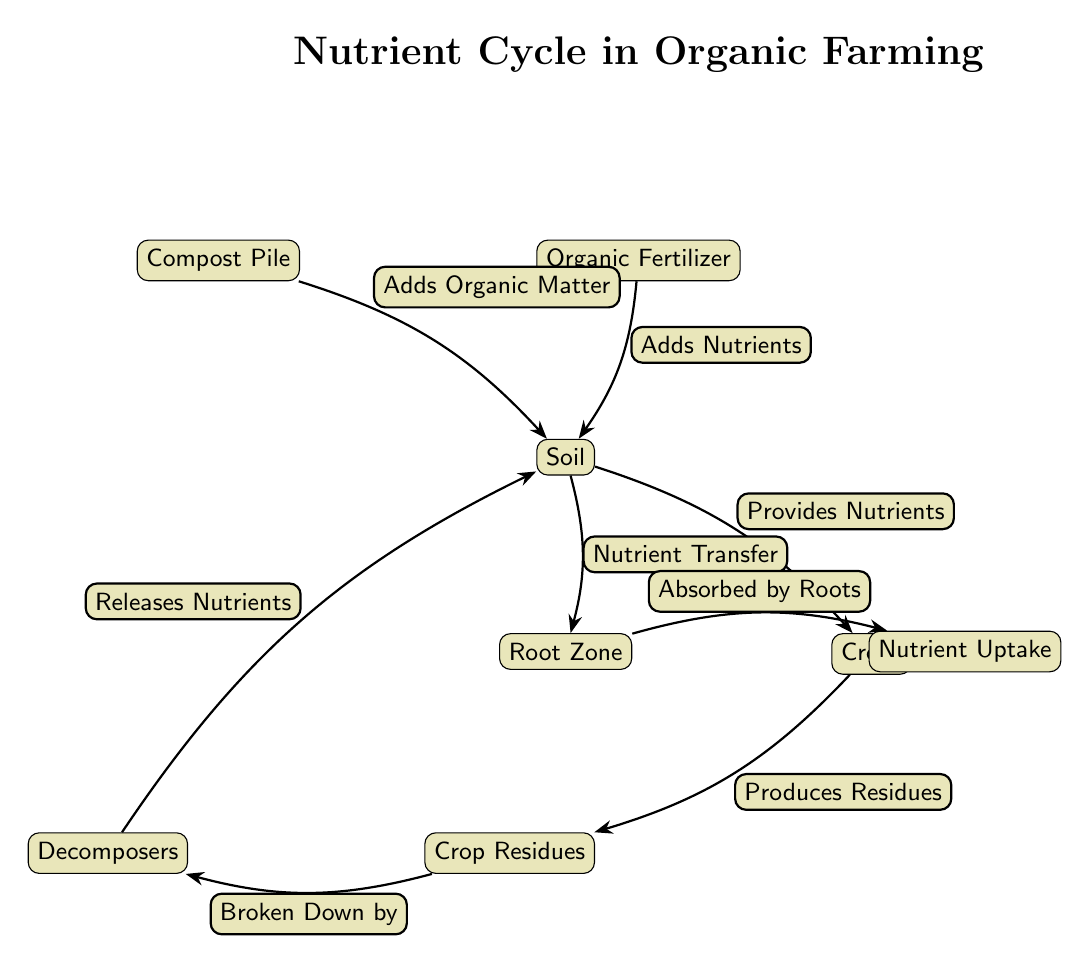What are the inputs to the soil? The diagram shows two inputs to the soil: "Compost Pile" and "Organic Fertilizer." Both are directly connected to the soil node with labels indicating their roles.
Answer: Compost Pile, Organic Fertilizer How many nodes are in the diagram? By counting all distinct elements in the diagram, including inputs, soil, crops, residues, decomposers, root zone, and nutrient uptake, we find there are a total of 7 nodes.
Answer: 7 What do decomposers do in the diagram? The diagram indicates that decomposers "Broken Down by" crop residues and "Releases Nutrients," showing their key role in nutrient recycling in the soil.
Answer: Releases Nutrients What is transferred from the soil to the root zone? The diagram illustrates that "Nutrient Transfer" occurs from the soil to the root zone, indicating the flow of nutrients necessary for crop growth.
Answer: Nutrients Which node produces crop residues? Looking at the diagrams, the "Crops" node is indicated to produce crop residues, which are then connected to the decomposers for further breakdown.
Answer: Crops What happens after organic matter is added to the soil? The diagram shows that after organic matter (from compost and fertilizers) is added to the soil, it provides nutrients to the crops, thereby supporting their growth.
Answer: Provides Nutrients What connects the root zone to nutrient uptake? The edge is labeled "Absorbed by Roots," illustrating how nutrients travel from the root zone to the nutrient uptake process in crops.
Answer: Absorbed by Roots What is the relationship between crop residues and decomposers? The diagram specifies that crop residues are "Broken Down by" decomposers, signifying the critical process of decomposition that releases nutrients back into the soil.
Answer: Broken Down by What are the roles of compost and organic fertilizer in the nutrient cycle? Both compost and organic fertilizer are shown to "Adds Organic Matter" and "Adds Nutrients" respectively, playing crucial roles in enhancing soil fertility and providing essential minerals.
Answer: Adds Organic Matter, Adds Nutrients 